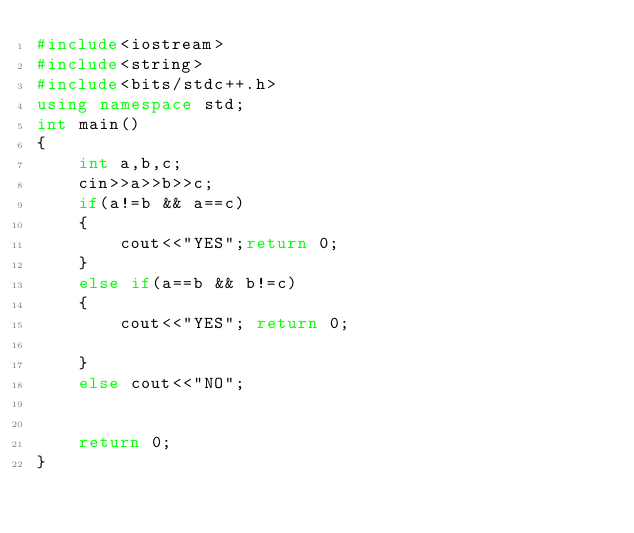<code> <loc_0><loc_0><loc_500><loc_500><_C++_>#include<iostream>
#include<string>
#include<bits/stdc++.h>
using namespace std;
int main()
{
    int a,b,c;
    cin>>a>>b>>c;
    if(a!=b && a==c)
    {
        cout<<"YES";return 0;
    }
    else if(a==b && b!=c)
    {
        cout<<"YES"; return 0;

    }
    else cout<<"NO";


    return 0;
}
</code> 